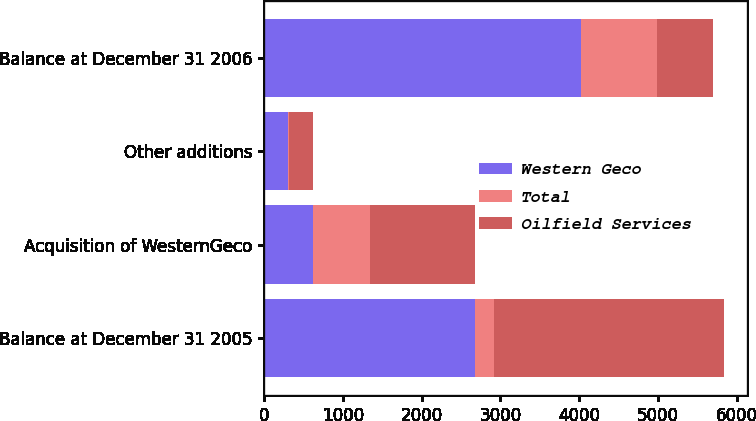Convert chart. <chart><loc_0><loc_0><loc_500><loc_500><stacked_bar_chart><ecel><fcel>Balance at December 31 2005<fcel>Acquisition of WesternGeco<fcel>Other additions<fcel>Balance at December 31 2006<nl><fcel>Western Geco<fcel>2676<fcel>625<fcel>301<fcel>4021<nl><fcel>Total<fcel>246<fcel>713<fcel>9<fcel>968<nl><fcel>Oilfield Services<fcel>2922<fcel>1338<fcel>310<fcel>713<nl></chart> 